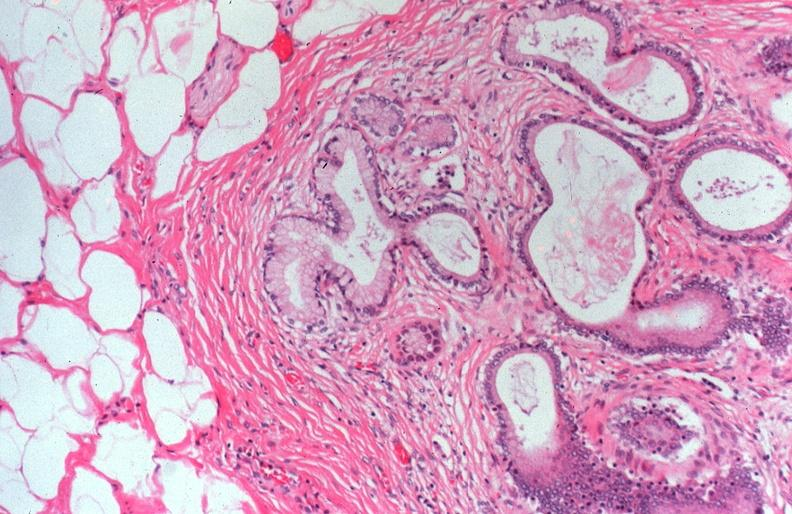where is this?
Answer the question using a single word or phrase. Pancreas 